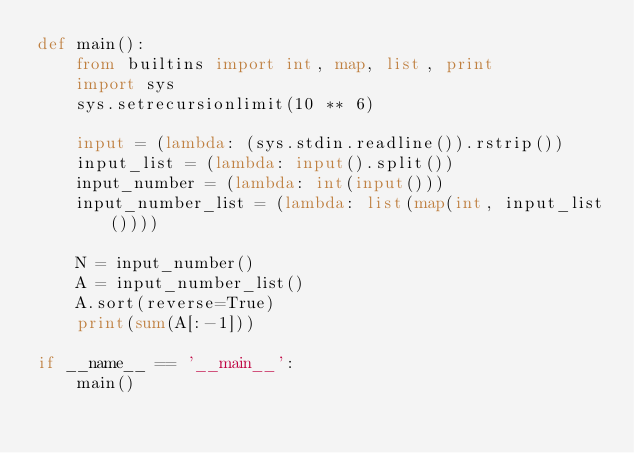<code> <loc_0><loc_0><loc_500><loc_500><_Python_>def main():
    from builtins import int, map, list, print
    import sys
    sys.setrecursionlimit(10 ** 6)

    input = (lambda: (sys.stdin.readline()).rstrip())
    input_list = (lambda: input().split())
    input_number = (lambda: int(input()))
    input_number_list = (lambda: list(map(int, input_list())))

    N = input_number()
    A = input_number_list()
    A.sort(reverse=True)
    print(sum(A[:-1]))

if __name__ == '__main__':
    main()
</code> 